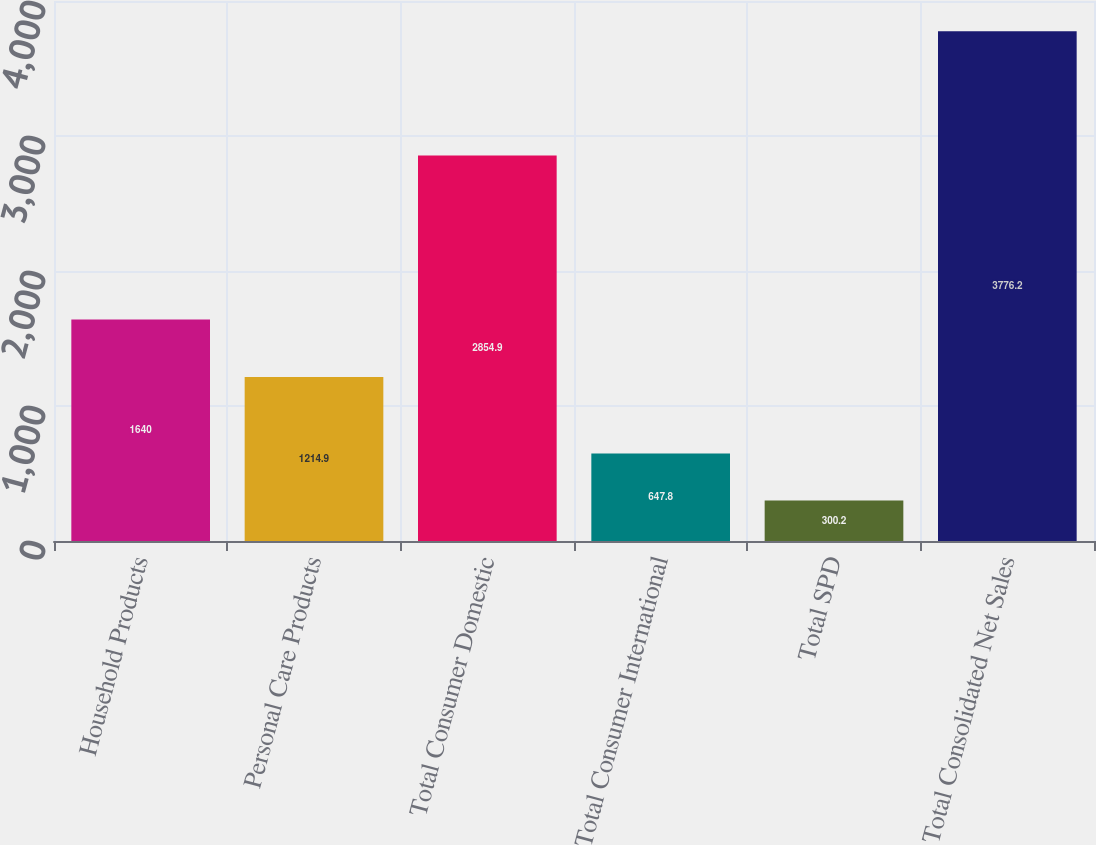Convert chart to OTSL. <chart><loc_0><loc_0><loc_500><loc_500><bar_chart><fcel>Household Products<fcel>Personal Care Products<fcel>Total Consumer Domestic<fcel>Total Consumer International<fcel>Total SPD<fcel>Total Consolidated Net Sales<nl><fcel>1640<fcel>1214.9<fcel>2854.9<fcel>647.8<fcel>300.2<fcel>3776.2<nl></chart> 